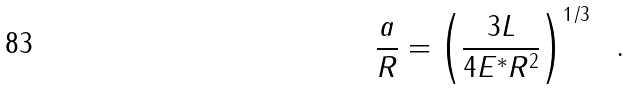Convert formula to latex. <formula><loc_0><loc_0><loc_500><loc_500>\frac { a } { R } = \left ( \frac { 3 L } { 4 E ^ { * } R ^ { 2 } } \right ) ^ { 1 / 3 } \ \ .</formula> 